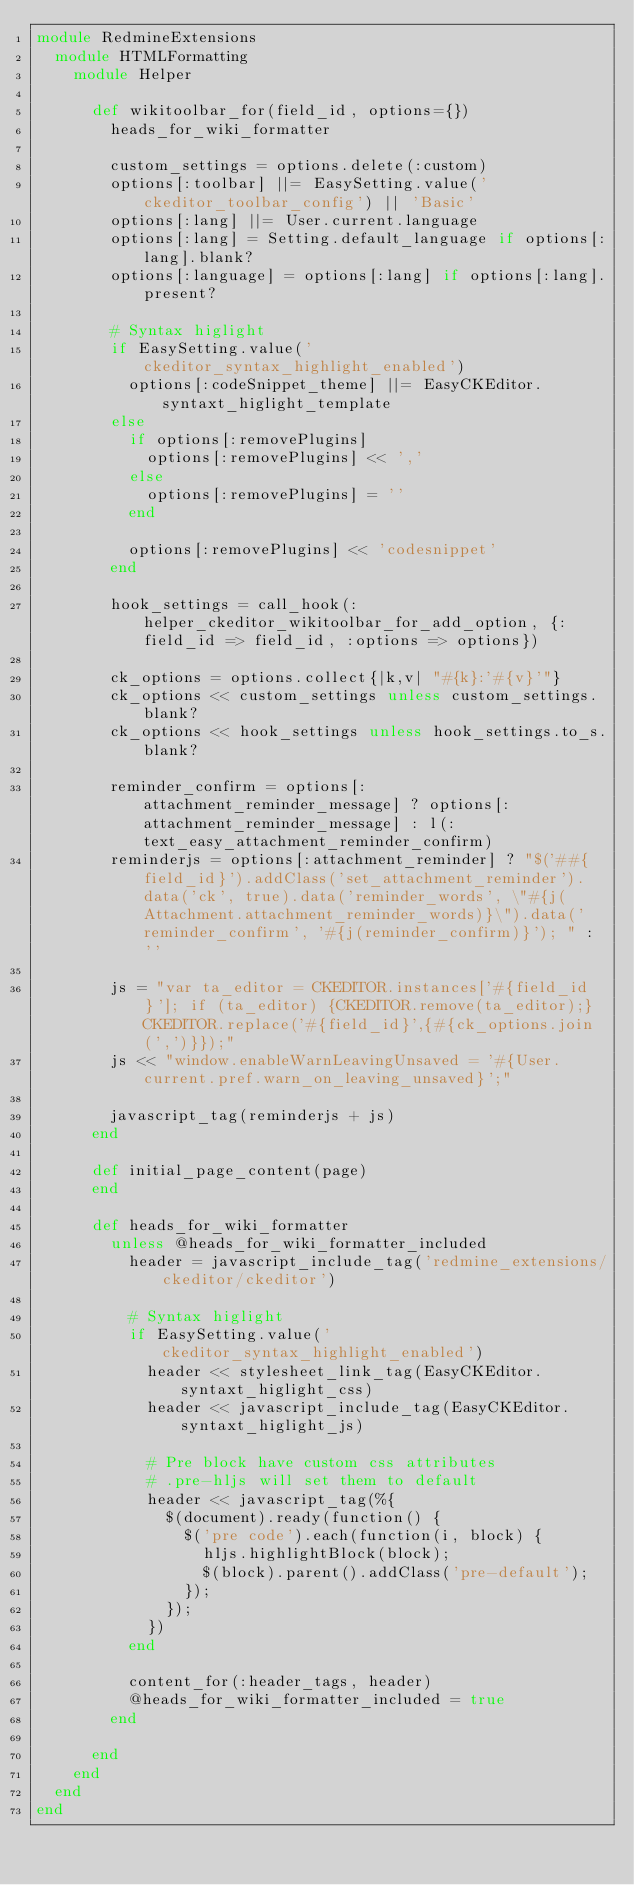<code> <loc_0><loc_0><loc_500><loc_500><_Ruby_>module RedmineExtensions
  module HTMLFormatting
    module Helper

      def wikitoolbar_for(field_id, options={})
        heads_for_wiki_formatter

        custom_settings = options.delete(:custom)
        options[:toolbar] ||= EasySetting.value('ckeditor_toolbar_config') || 'Basic'
        options[:lang] ||= User.current.language
        options[:lang] = Setting.default_language if options[:lang].blank?
        options[:language] = options[:lang] if options[:lang].present?

        # Syntax higlight
        if EasySetting.value('ckeditor_syntax_highlight_enabled')
          options[:codeSnippet_theme] ||= EasyCKEditor.syntaxt_higlight_template
        else
          if options[:removePlugins]
            options[:removePlugins] << ','
          else
            options[:removePlugins] = ''
          end

          options[:removePlugins] << 'codesnippet'
        end

        hook_settings = call_hook(:helper_ckeditor_wikitoolbar_for_add_option, {:field_id => field_id, :options => options})

        ck_options = options.collect{|k,v| "#{k}:'#{v}'"}
        ck_options << custom_settings unless custom_settings.blank?
        ck_options << hook_settings unless hook_settings.to_s.blank?

        reminder_confirm = options[:attachment_reminder_message] ? options[:attachment_reminder_message] : l(:text_easy_attachment_reminder_confirm)
        reminderjs = options[:attachment_reminder] ? "$('##{field_id}').addClass('set_attachment_reminder').data('ck', true).data('reminder_words', \"#{j(Attachment.attachment_reminder_words)}\").data('reminder_confirm', '#{j(reminder_confirm)}'); " : ''

        js = "var ta_editor = CKEDITOR.instances['#{field_id}']; if (ta_editor) {CKEDITOR.remove(ta_editor);} CKEDITOR.replace('#{field_id}',{#{ck_options.join(',')}});"
        js << "window.enableWarnLeavingUnsaved = '#{User.current.pref.warn_on_leaving_unsaved}';"

        javascript_tag(reminderjs + js)
      end

      def initial_page_content(page)
      end

      def heads_for_wiki_formatter
        unless @heads_for_wiki_formatter_included
          header = javascript_include_tag('redmine_extensions/ckeditor/ckeditor')

          # Syntax higlight
          if EasySetting.value('ckeditor_syntax_highlight_enabled')
            header << stylesheet_link_tag(EasyCKEditor.syntaxt_higlight_css)
            header << javascript_include_tag(EasyCKEditor.syntaxt_higlight_js)

            # Pre block have custom css attributes
            # .pre-hljs will set them to default
            header << javascript_tag(%{
              $(document).ready(function() {
                $('pre code').each(function(i, block) {
                  hljs.highlightBlock(block);
                  $(block).parent().addClass('pre-default');
                });
              });
            })
          end

          content_for(:header_tags, header)
          @heads_for_wiki_formatter_included = true
        end

      end
    end
  end
end
</code> 